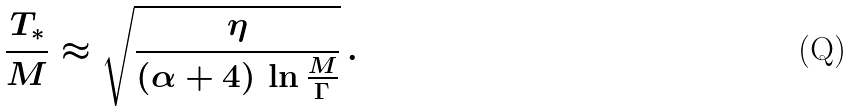Convert formula to latex. <formula><loc_0><loc_0><loc_500><loc_500>\frac { T _ { * } } { M } \approx \sqrt { \frac { \eta } { ( \alpha + 4 ) \, \ln \frac { M } { \Gamma } } } \, .</formula> 